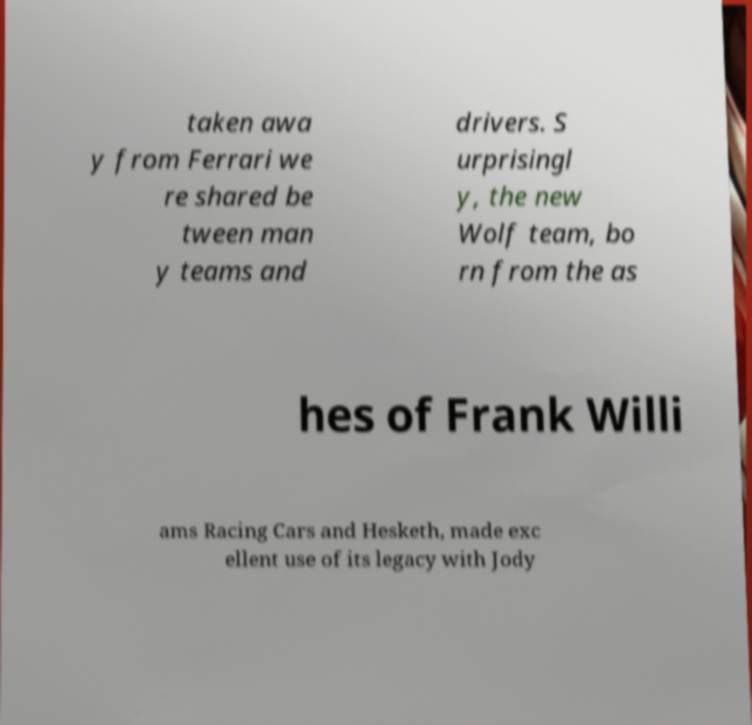Could you extract and type out the text from this image? taken awa y from Ferrari we re shared be tween man y teams and drivers. S urprisingl y, the new Wolf team, bo rn from the as hes of Frank Willi ams Racing Cars and Hesketh, made exc ellent use of its legacy with Jody 